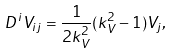Convert formula to latex. <formula><loc_0><loc_0><loc_500><loc_500>D ^ { i } V _ { i j } = \frac { 1 } { 2 k _ { V } ^ { 2 } } ( k _ { V } ^ { 2 } - 1 ) V _ { j } ,</formula> 